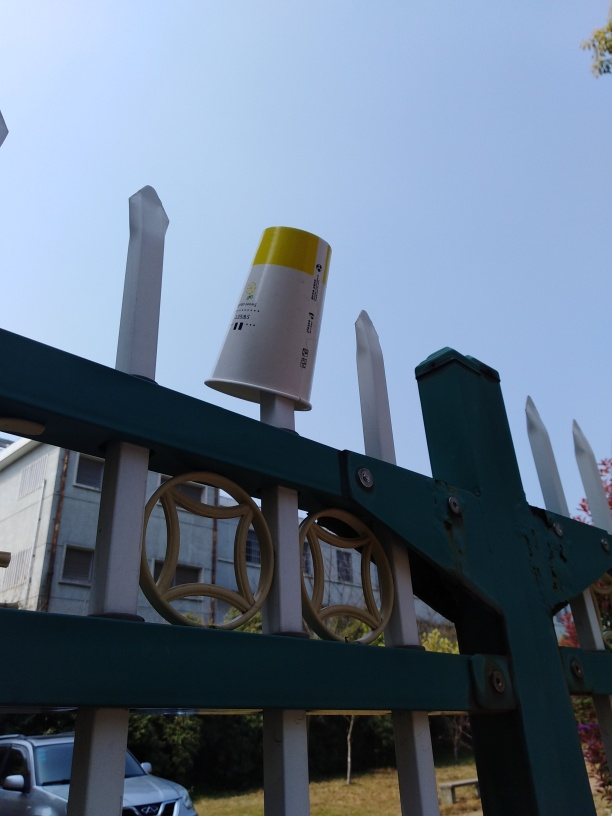What could be the significance of the cup placed on the fence post? The cup on the fence post is an interesting detail. It could suggest a moment of carelessness where someone placed their drink temporarily and forgot it, or it might symbolize the often overlooked everyday objects in our surroundings. Its presence against the backdrop of an urban environment invites contemplation about consumption and littering in public spaces. 